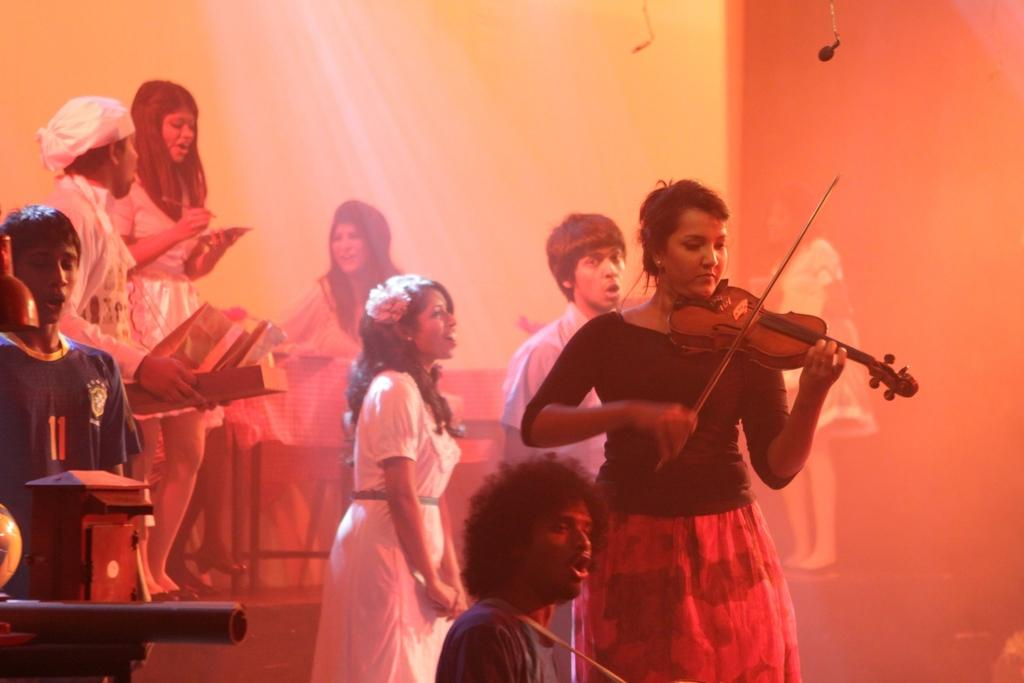How many people are present in the image? There are multiple people in the image. What is the woman doing in the image? The woman is holding a musical instrument. Can you describe the action of one of the people in the image? A person is holding something in their hand. What is the opinion of the dog in the image? There is no dog present in the image, so it is not possible to determine its opinion. 